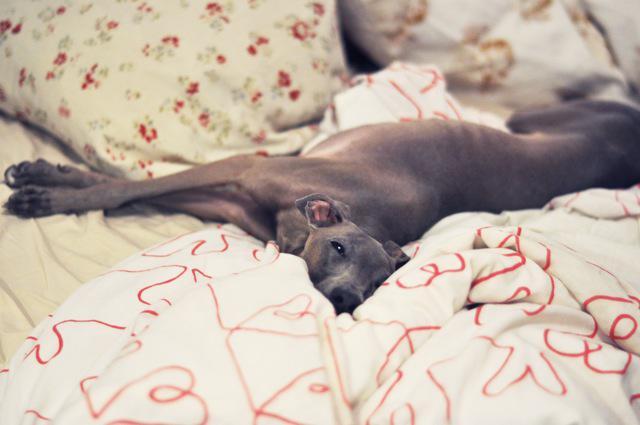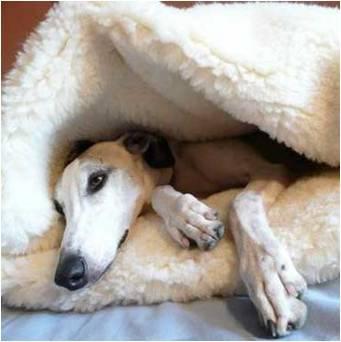The first image is the image on the left, the second image is the image on the right. Assess this claim about the two images: "A dog is sleeping with another dog in at least one picture.". Correct or not? Answer yes or no. No. The first image is the image on the left, the second image is the image on the right. Evaluate the accuracy of this statement regarding the images: "There are a total of three dogs.". Is it true? Answer yes or no. No. 